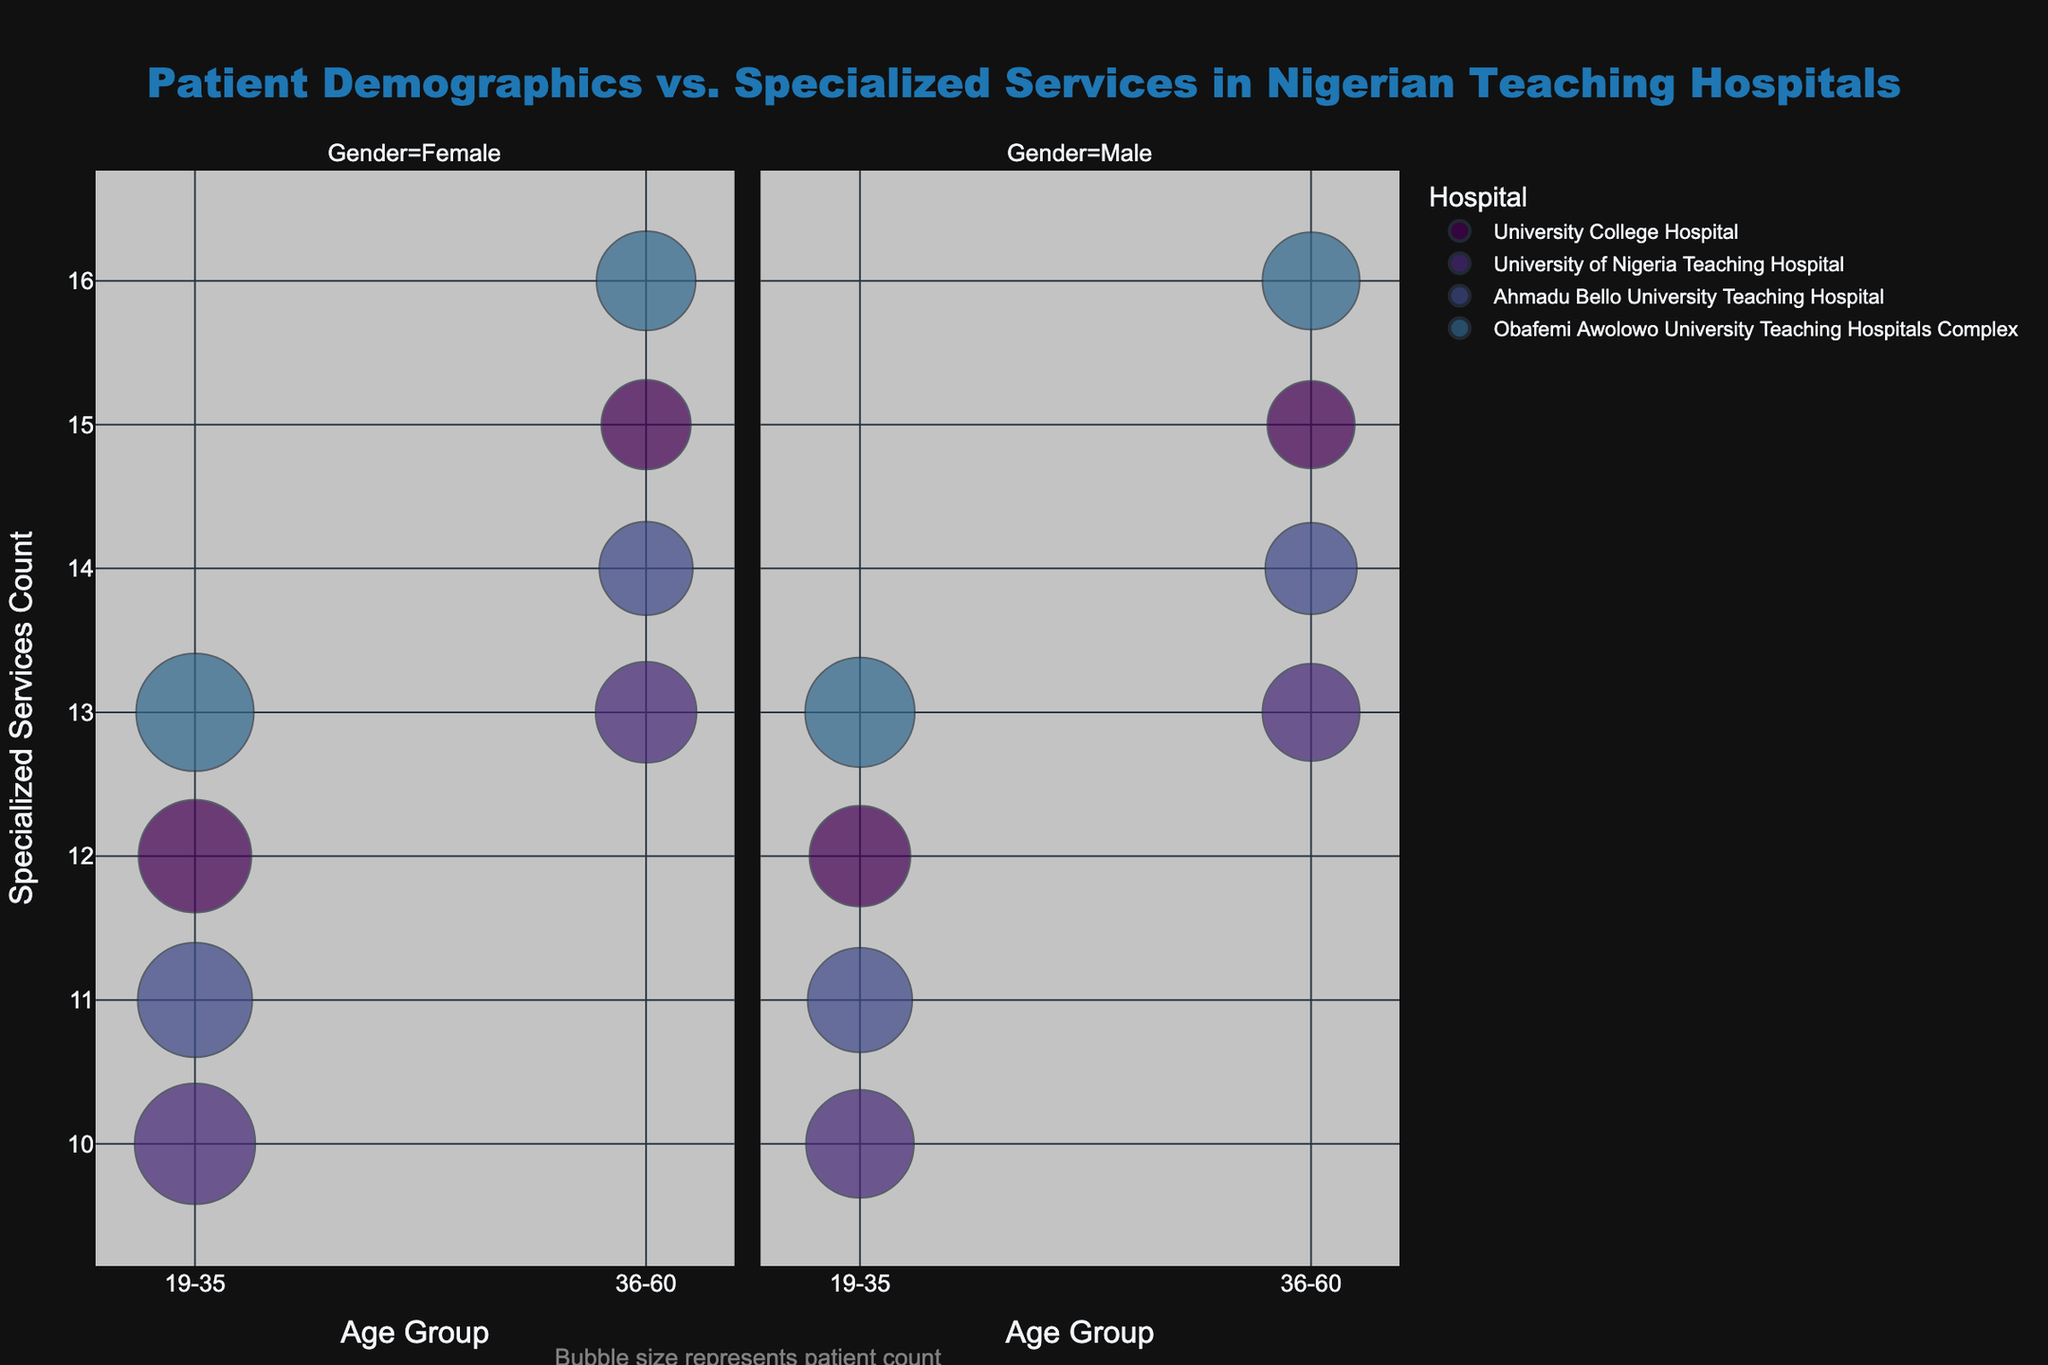How many hospitals are shown in the figure? The number of unique hospitals can be identified by observing the distinct colors that represent each hospital in the figure's legend.
Answer: 4 Which hospital has the most specialized services for both age groups and genders? By comparing the maximum value of the "Specialized Services Count" on the y-axis for each hospital, we can determine that Obafemi Awolowo University Teaching Hospitals Complex has the highest count of 16 services, indicating it has the most specialized services.
Answer: Obafemi Awolowo University Teaching Hospitals Complex What is the total number of patients in the age group 19-35 at University College Hospital? Summing up the "Patients Count" for both females and males in the 19-35 age group at University College Hospital from the bubble sizes: 3500 (Female) + 2800 (Male) = 6300.
Answer: 6300 Which gender has more patients in the age group 36-60 at Ahmadu Bello University Teaching Hospital? By examining the bubble sizes for the 36-60 age group at Ahmadu Bello University Teaching Hospital, we see that the female bubble size represents 2400 patients, and the male bubble size represents 2300 patients. Therefore, females have more patients.
Answer: Female Among all hospitals, which one has the largest bubble size in the figure? The largest bubble size represents the highest patient count. By visually identifying the largest bubble in the figure, we see that University of Nigeria Teaching Hospital has a bubble size representing 4000 patients.
Answer: University of Nigeria Teaching Hospital How does the availability of specialized services differ between genders for the 36-60 age group at Obafemi Awolowo University Teaching Hospitals Complex? Comparing the "Specialized Services Count" on the y-axis for males and females in the 36-60 age group at Obafemi Awolowo University Teaching Hospitals Complex, both genders have the same count of 16 specialized services.
Answer: They are the same Which hospital has the lowest patient count for males in the 19-35 age group? By examining the bubble sizes for males in the 19-35 age group, the smallest bubble size corresponding to the lowest patient count is found at University College Hospital with 2800 patients.
Answer: University College Hospital What is the average number of specialized services provided by hospitals for the 19-35 age group? Sum the "Specialized Services Count" for the 19-35 age group across all hospitals and divide by the number of hospitals: (12+10+11+13) / 4 = 11.5 for females and the same for males since the counts are identical for both genders.
Answer: 11.5 